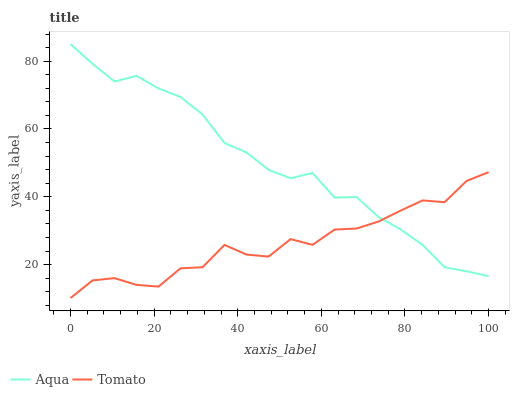Does Tomato have the minimum area under the curve?
Answer yes or no. Yes. Does Aqua have the maximum area under the curve?
Answer yes or no. Yes. Does Aqua have the minimum area under the curve?
Answer yes or no. No. Is Aqua the smoothest?
Answer yes or no. Yes. Is Tomato the roughest?
Answer yes or no. Yes. Is Aqua the roughest?
Answer yes or no. No. Does Tomato have the lowest value?
Answer yes or no. Yes. Does Aqua have the lowest value?
Answer yes or no. No. Does Aqua have the highest value?
Answer yes or no. Yes. Does Tomato intersect Aqua?
Answer yes or no. Yes. Is Tomato less than Aqua?
Answer yes or no. No. Is Tomato greater than Aqua?
Answer yes or no. No. 